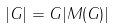Convert formula to latex. <formula><loc_0><loc_0><loc_500><loc_500>| G | = \| G \| | M ( G ) |</formula> 